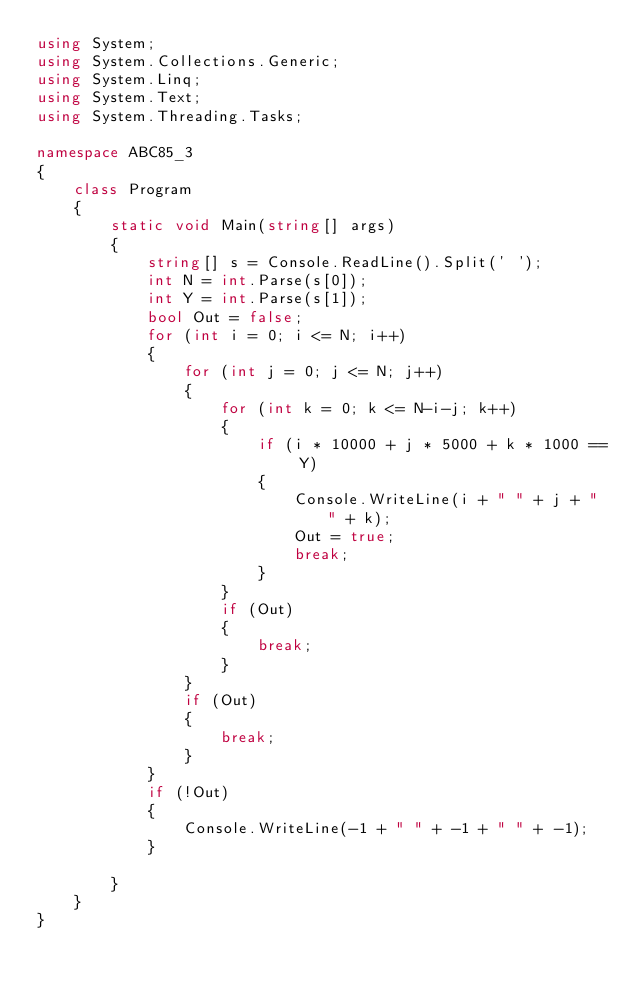Convert code to text. <code><loc_0><loc_0><loc_500><loc_500><_C#_>using System;
using System.Collections.Generic;
using System.Linq;
using System.Text;
using System.Threading.Tasks;

namespace ABC85_3
{
    class Program
    {
        static void Main(string[] args)
        {
            string[] s = Console.ReadLine().Split(' ');
            int N = int.Parse(s[0]);
            int Y = int.Parse(s[1]);
            bool Out = false;
            for (int i = 0; i <= N; i++)
            {
                for (int j = 0; j <= N; j++)
                {
                    for (int k = 0; k <= N-i-j; k++)
                    {
                        if (i * 10000 + j * 5000 + k * 1000 == Y)
                        {
                            Console.WriteLine(i + " " + j + " " + k);
                            Out = true;
                            break;
                        }
                    }
                    if (Out)
                    {
                        break;
                    }
                }
                if (Out)
                {
                    break;
                }
            }
            if (!Out)
            {
                Console.WriteLine(-1 + " " + -1 + " " + -1);
            }

        }
    }
}
</code> 